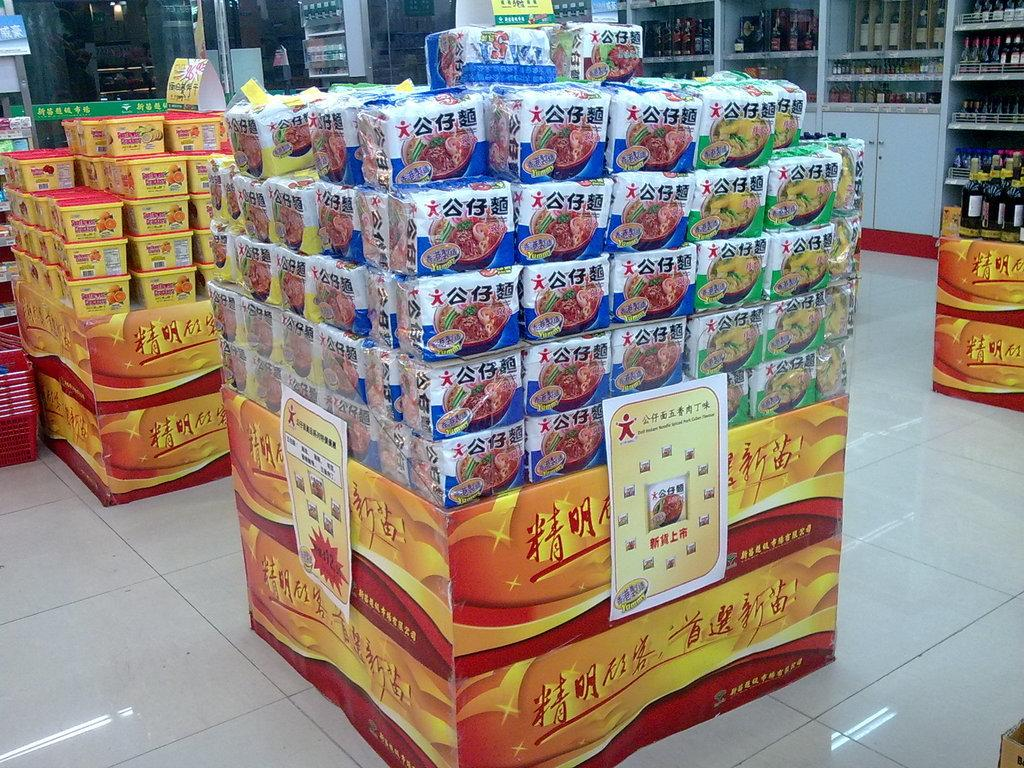What type of items are covered in plastic in the image? There are items in plastic covers in the image. Where are the boxes located in the image? The boxes are on the left side of the image. What can be seen on the shelves in the background of the image? There are shelves with bottles in the background of the image. What type of location does the image appear to depict? The image appears to depict a store. What type of writing can be seen on the boxes in the image? There is no mention of writing on the boxes in the image. Is the grandfather present in the image? There is no mention of a grandfather in the image. 